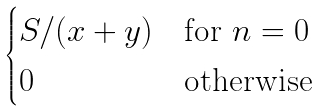<formula> <loc_0><loc_0><loc_500><loc_500>\begin{cases} S / ( x + y ) & \text {for } n = 0 \\ 0 & \text {otherwise} \end{cases}</formula> 